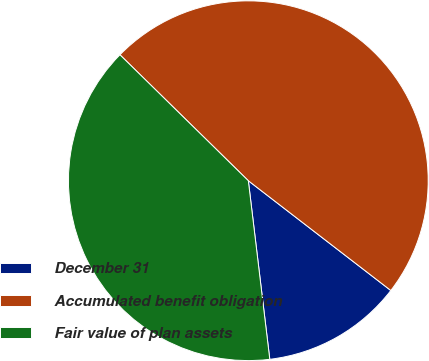<chart> <loc_0><loc_0><loc_500><loc_500><pie_chart><fcel>December 31<fcel>Accumulated benefit obligation<fcel>Fair value of plan assets<nl><fcel>12.65%<fcel>48.1%<fcel>39.25%<nl></chart> 